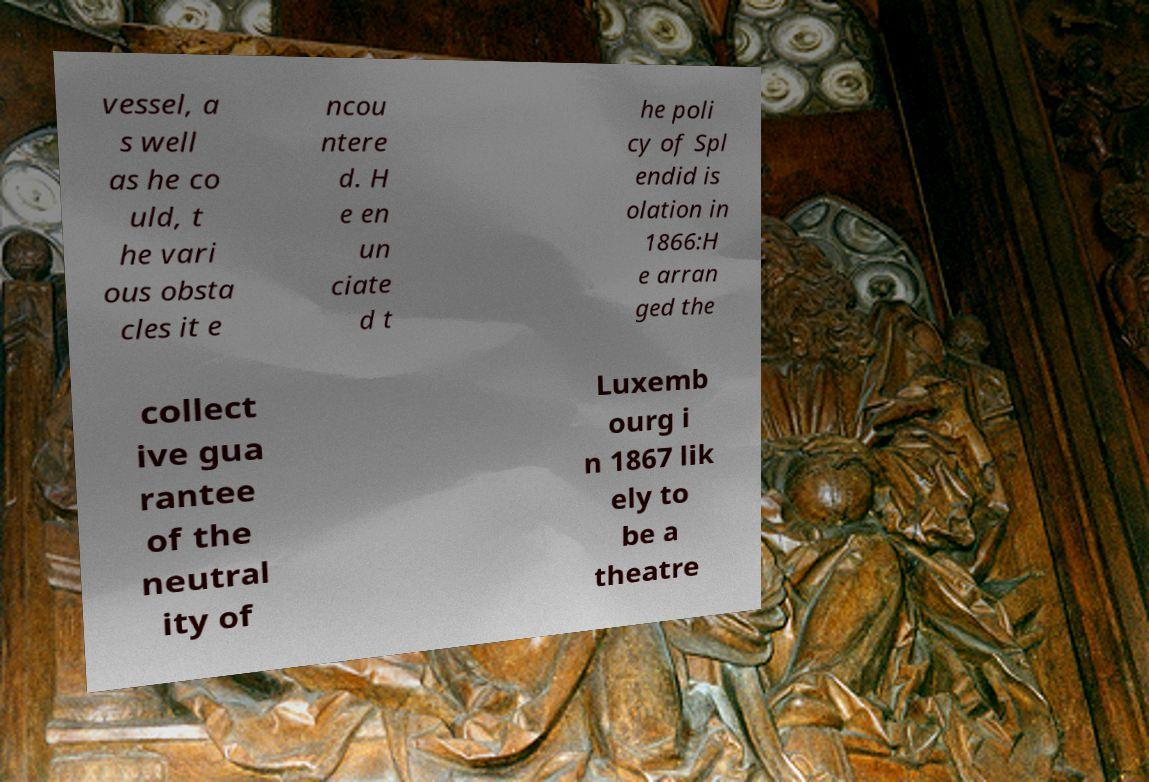Can you read and provide the text displayed in the image?This photo seems to have some interesting text. Can you extract and type it out for me? vessel, a s well as he co uld, t he vari ous obsta cles it e ncou ntere d. H e en un ciate d t he poli cy of Spl endid is olation in 1866:H e arran ged the collect ive gua rantee of the neutral ity of Luxemb ourg i n 1867 lik ely to be a theatre 